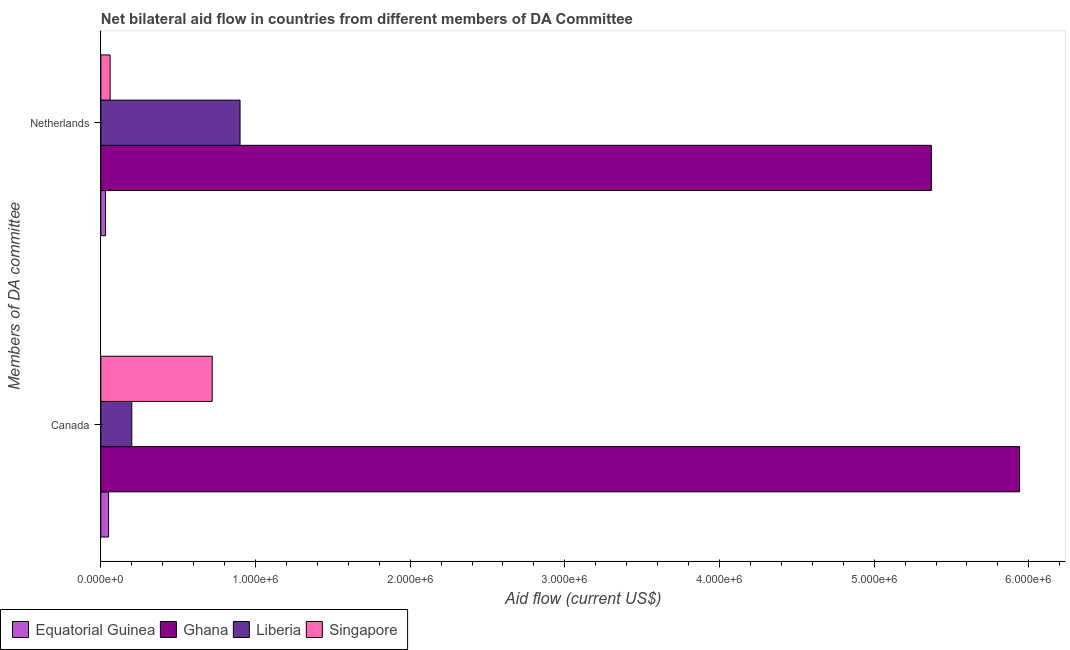Are the number of bars on each tick of the Y-axis equal?
Provide a succinct answer. Yes. How many bars are there on the 2nd tick from the top?
Your answer should be compact. 4. What is the label of the 1st group of bars from the top?
Make the answer very short. Netherlands. What is the amount of aid given by netherlands in Equatorial Guinea?
Ensure brevity in your answer.  3.00e+04. Across all countries, what is the maximum amount of aid given by netherlands?
Make the answer very short. 5.37e+06. Across all countries, what is the minimum amount of aid given by netherlands?
Your answer should be very brief. 3.00e+04. In which country was the amount of aid given by netherlands minimum?
Your answer should be very brief. Equatorial Guinea. What is the total amount of aid given by canada in the graph?
Provide a short and direct response. 6.91e+06. What is the difference between the amount of aid given by netherlands in Singapore and that in Equatorial Guinea?
Keep it short and to the point. 3.00e+04. What is the difference between the amount of aid given by netherlands in Singapore and the amount of aid given by canada in Liberia?
Provide a succinct answer. -1.40e+05. What is the average amount of aid given by netherlands per country?
Make the answer very short. 1.59e+06. What is the difference between the amount of aid given by canada and amount of aid given by netherlands in Equatorial Guinea?
Provide a short and direct response. 2.00e+04. What is the ratio of the amount of aid given by netherlands in Singapore to that in Ghana?
Your answer should be compact. 0.01. Is the amount of aid given by netherlands in Singapore less than that in Equatorial Guinea?
Provide a succinct answer. No. What does the 1st bar from the top in Netherlands represents?
Keep it short and to the point. Singapore. What does the 3rd bar from the bottom in Canada represents?
Make the answer very short. Liberia. Are the values on the major ticks of X-axis written in scientific E-notation?
Your answer should be compact. Yes. How many legend labels are there?
Your response must be concise. 4. How are the legend labels stacked?
Offer a very short reply. Horizontal. What is the title of the graph?
Ensure brevity in your answer.  Net bilateral aid flow in countries from different members of DA Committee. Does "Gambia, The" appear as one of the legend labels in the graph?
Provide a short and direct response. No. What is the label or title of the Y-axis?
Offer a very short reply. Members of DA committee. What is the Aid flow (current US$) of Ghana in Canada?
Make the answer very short. 5.94e+06. What is the Aid flow (current US$) of Singapore in Canada?
Your answer should be very brief. 7.20e+05. What is the Aid flow (current US$) of Ghana in Netherlands?
Make the answer very short. 5.37e+06. What is the Aid flow (current US$) of Liberia in Netherlands?
Ensure brevity in your answer.  9.00e+05. What is the Aid flow (current US$) of Singapore in Netherlands?
Provide a succinct answer. 6.00e+04. Across all Members of DA committee, what is the maximum Aid flow (current US$) of Ghana?
Offer a terse response. 5.94e+06. Across all Members of DA committee, what is the maximum Aid flow (current US$) in Liberia?
Offer a terse response. 9.00e+05. Across all Members of DA committee, what is the maximum Aid flow (current US$) of Singapore?
Ensure brevity in your answer.  7.20e+05. Across all Members of DA committee, what is the minimum Aid flow (current US$) of Equatorial Guinea?
Provide a succinct answer. 3.00e+04. Across all Members of DA committee, what is the minimum Aid flow (current US$) of Ghana?
Your answer should be very brief. 5.37e+06. Across all Members of DA committee, what is the minimum Aid flow (current US$) of Singapore?
Provide a short and direct response. 6.00e+04. What is the total Aid flow (current US$) of Ghana in the graph?
Offer a very short reply. 1.13e+07. What is the total Aid flow (current US$) in Liberia in the graph?
Your response must be concise. 1.10e+06. What is the total Aid flow (current US$) of Singapore in the graph?
Provide a succinct answer. 7.80e+05. What is the difference between the Aid flow (current US$) in Ghana in Canada and that in Netherlands?
Your answer should be compact. 5.70e+05. What is the difference between the Aid flow (current US$) of Liberia in Canada and that in Netherlands?
Ensure brevity in your answer.  -7.00e+05. What is the difference between the Aid flow (current US$) of Equatorial Guinea in Canada and the Aid flow (current US$) of Ghana in Netherlands?
Give a very brief answer. -5.32e+06. What is the difference between the Aid flow (current US$) in Equatorial Guinea in Canada and the Aid flow (current US$) in Liberia in Netherlands?
Provide a short and direct response. -8.50e+05. What is the difference between the Aid flow (current US$) of Equatorial Guinea in Canada and the Aid flow (current US$) of Singapore in Netherlands?
Keep it short and to the point. -10000. What is the difference between the Aid flow (current US$) in Ghana in Canada and the Aid flow (current US$) in Liberia in Netherlands?
Your answer should be very brief. 5.04e+06. What is the difference between the Aid flow (current US$) in Ghana in Canada and the Aid flow (current US$) in Singapore in Netherlands?
Keep it short and to the point. 5.88e+06. What is the difference between the Aid flow (current US$) in Liberia in Canada and the Aid flow (current US$) in Singapore in Netherlands?
Make the answer very short. 1.40e+05. What is the average Aid flow (current US$) in Ghana per Members of DA committee?
Provide a succinct answer. 5.66e+06. What is the average Aid flow (current US$) of Liberia per Members of DA committee?
Provide a succinct answer. 5.50e+05. What is the average Aid flow (current US$) of Singapore per Members of DA committee?
Give a very brief answer. 3.90e+05. What is the difference between the Aid flow (current US$) in Equatorial Guinea and Aid flow (current US$) in Ghana in Canada?
Keep it short and to the point. -5.89e+06. What is the difference between the Aid flow (current US$) in Equatorial Guinea and Aid flow (current US$) in Singapore in Canada?
Your response must be concise. -6.70e+05. What is the difference between the Aid flow (current US$) in Ghana and Aid flow (current US$) in Liberia in Canada?
Make the answer very short. 5.74e+06. What is the difference between the Aid flow (current US$) of Ghana and Aid flow (current US$) of Singapore in Canada?
Provide a short and direct response. 5.22e+06. What is the difference between the Aid flow (current US$) in Liberia and Aid flow (current US$) in Singapore in Canada?
Offer a terse response. -5.20e+05. What is the difference between the Aid flow (current US$) of Equatorial Guinea and Aid flow (current US$) of Ghana in Netherlands?
Offer a terse response. -5.34e+06. What is the difference between the Aid flow (current US$) of Equatorial Guinea and Aid flow (current US$) of Liberia in Netherlands?
Ensure brevity in your answer.  -8.70e+05. What is the difference between the Aid flow (current US$) of Equatorial Guinea and Aid flow (current US$) of Singapore in Netherlands?
Your answer should be very brief. -3.00e+04. What is the difference between the Aid flow (current US$) in Ghana and Aid flow (current US$) in Liberia in Netherlands?
Provide a short and direct response. 4.47e+06. What is the difference between the Aid flow (current US$) in Ghana and Aid flow (current US$) in Singapore in Netherlands?
Offer a terse response. 5.31e+06. What is the difference between the Aid flow (current US$) in Liberia and Aid flow (current US$) in Singapore in Netherlands?
Make the answer very short. 8.40e+05. What is the ratio of the Aid flow (current US$) in Equatorial Guinea in Canada to that in Netherlands?
Provide a succinct answer. 1.67. What is the ratio of the Aid flow (current US$) of Ghana in Canada to that in Netherlands?
Provide a short and direct response. 1.11. What is the ratio of the Aid flow (current US$) of Liberia in Canada to that in Netherlands?
Your answer should be very brief. 0.22. What is the difference between the highest and the second highest Aid flow (current US$) of Ghana?
Offer a very short reply. 5.70e+05. What is the difference between the highest and the second highest Aid flow (current US$) of Liberia?
Offer a very short reply. 7.00e+05. What is the difference between the highest and the second highest Aid flow (current US$) of Singapore?
Ensure brevity in your answer.  6.60e+05. What is the difference between the highest and the lowest Aid flow (current US$) of Equatorial Guinea?
Provide a short and direct response. 2.00e+04. What is the difference between the highest and the lowest Aid flow (current US$) of Ghana?
Give a very brief answer. 5.70e+05. 